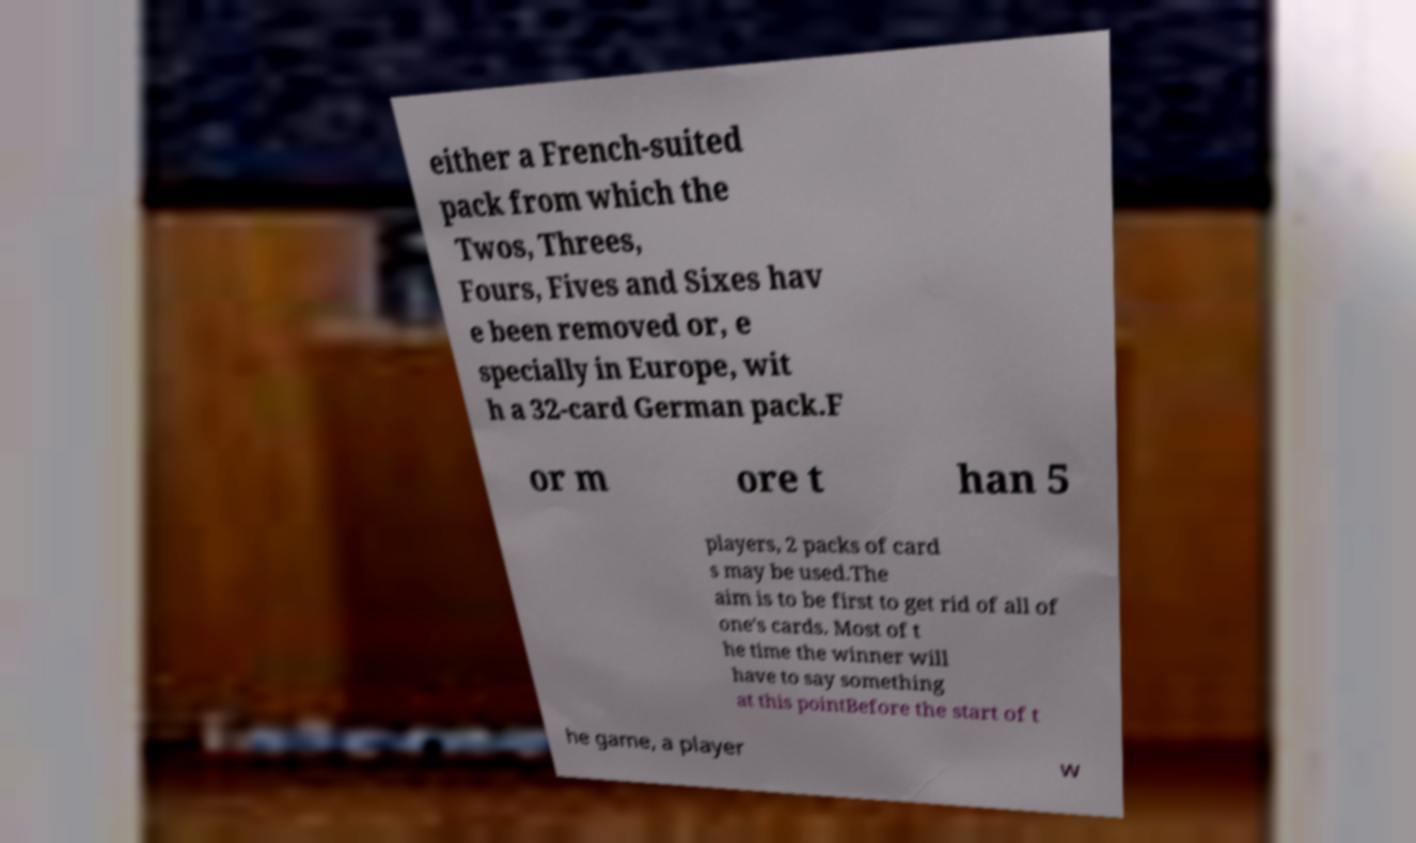For documentation purposes, I need the text within this image transcribed. Could you provide that? either a French-suited pack from which the Twos, Threes, Fours, Fives and Sixes hav e been removed or, e specially in Europe, wit h a 32-card German pack.F or m ore t han 5 players, 2 packs of card s may be used.The aim is to be first to get rid of all of one's cards. Most of t he time the winner will have to say something at this pointBefore the start of t he game, a player w 